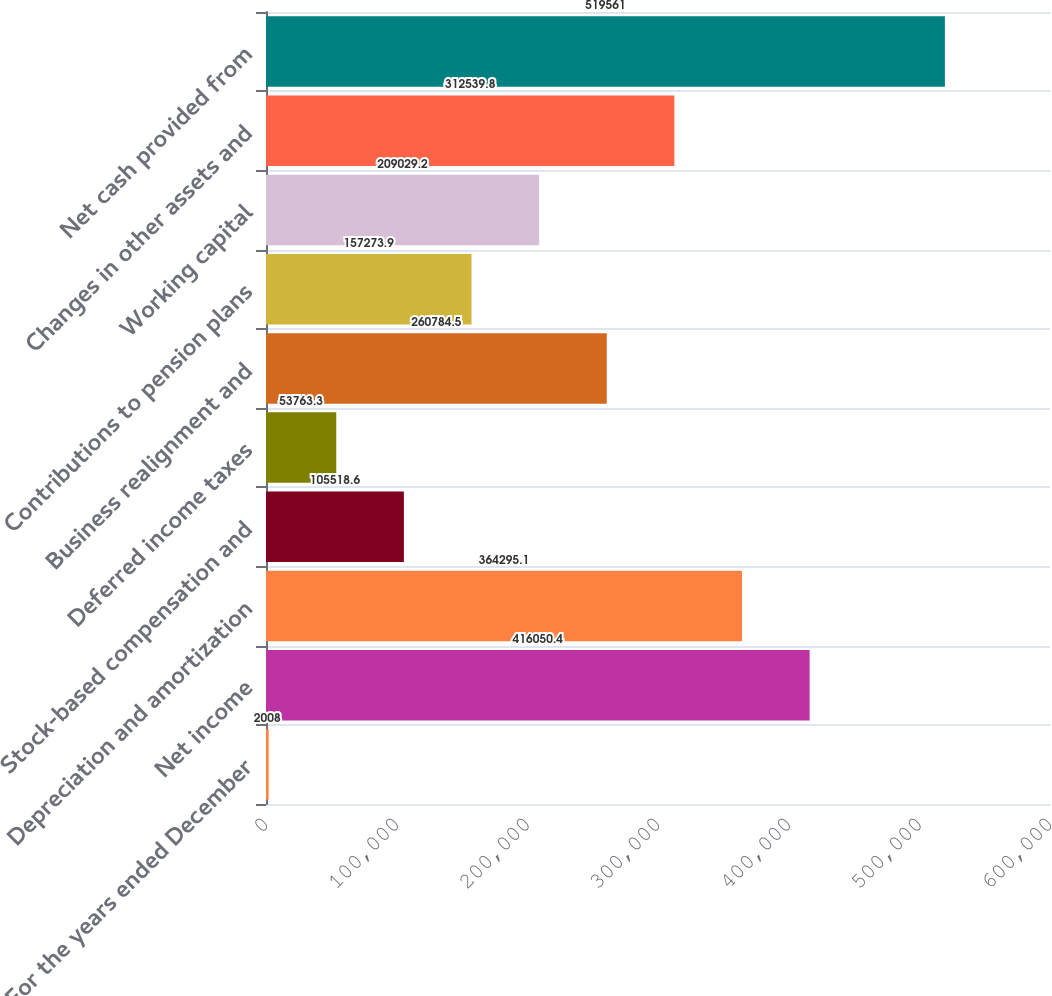Convert chart to OTSL. <chart><loc_0><loc_0><loc_500><loc_500><bar_chart><fcel>For the years ended December<fcel>Net income<fcel>Depreciation and amortization<fcel>Stock-based compensation and<fcel>Deferred income taxes<fcel>Business realignment and<fcel>Contributions to pension plans<fcel>Working capital<fcel>Changes in other assets and<fcel>Net cash provided from<nl><fcel>2008<fcel>416050<fcel>364295<fcel>105519<fcel>53763.3<fcel>260784<fcel>157274<fcel>209029<fcel>312540<fcel>519561<nl></chart> 